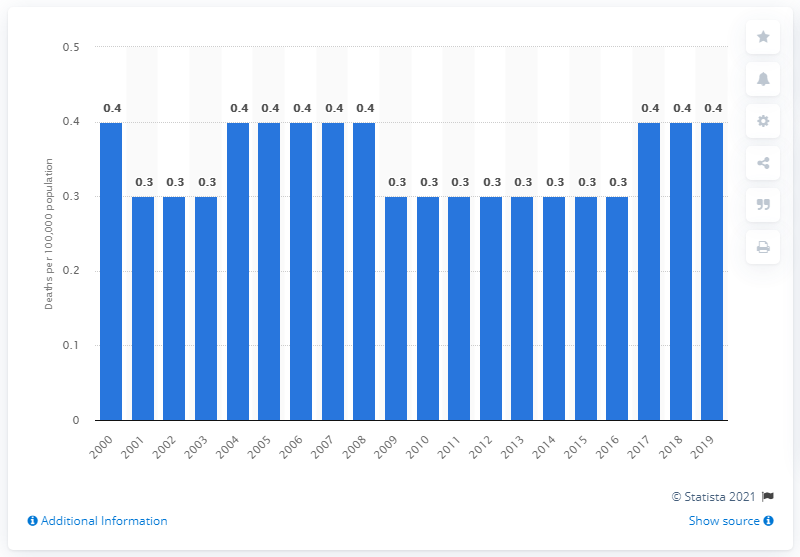Mention a couple of crucial points in this snapshot. The death rate for infections of the kidney was at the same level in 2000 as it did in that year. 